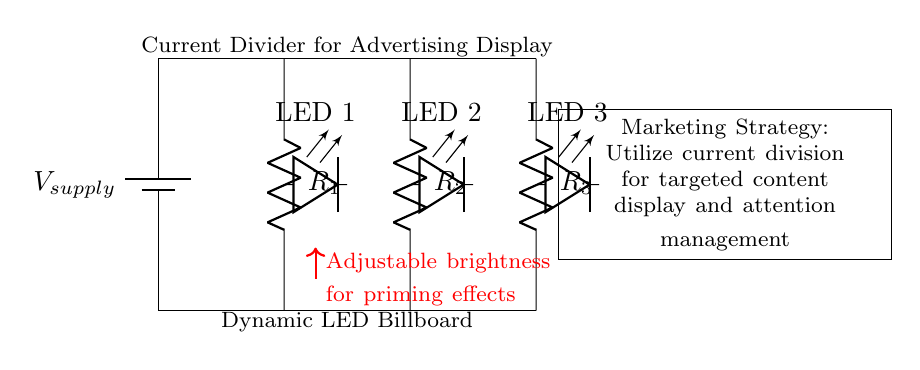What type of circuit is depicted? The circuit shown is a current divider, which distributes current across multiple branches according to their resistances.
Answer: Current divider How many resistors are in this circuit? The circuit contains three resistors connected in parallel.
Answer: Three What is the purpose of the adjustable brightness? The adjustable brightness allows for dynamic control over the LED's light output, which is essential for effective advertising strategies.
Answer: Dynamic control Which components are used as loads in the circuit? The loads in the circuit are LEDs, specifically LED 1, LED 2, and LED 3.
Answer: LEDs How does current division affect LED brightness? Current division impacts the brightness of each LED by sharing total current inversely proportional to their resistances, thus influencing the voltage drop across each LED.
Answer: Voltage drop What marketing advantage does this circuit provide? This circuit enables targeted content display and attention management by adjusting LED brightness based on content needs.
Answer: Targeted content What is the connection type for the resistors? The resistors are connected in parallel, ensuring the total voltage is the same across all branches.
Answer: Parallel 